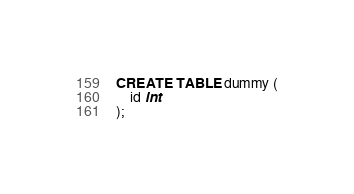Convert code to text. <code><loc_0><loc_0><loc_500><loc_500><_SQL_>CREATE TABLE dummy (
    id int
);</code> 